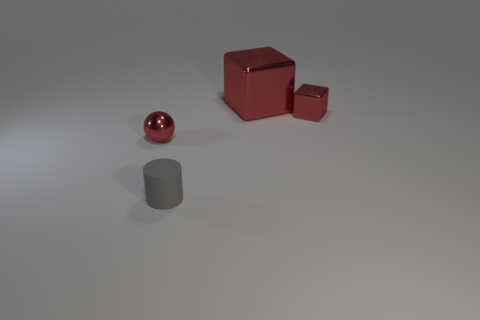Add 1 tiny metallic things. How many objects exist? 5 Add 2 red blocks. How many red blocks are left? 4 Add 4 gray rubber things. How many gray rubber things exist? 5 Subtract 0 brown cylinders. How many objects are left? 4 Subtract all cylinders. How many objects are left? 3 Subtract all rubber objects. Subtract all gray rubber cylinders. How many objects are left? 2 